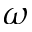<formula> <loc_0><loc_0><loc_500><loc_500>\omega</formula> 